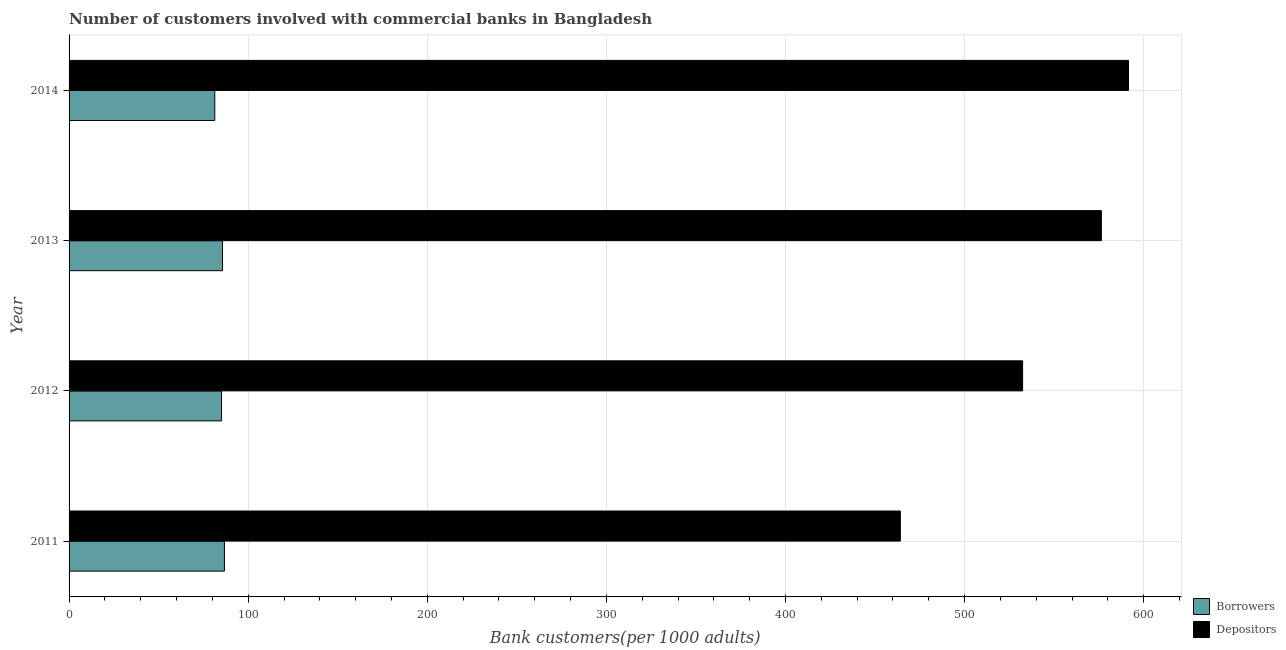How many groups of bars are there?
Your answer should be compact. 4. Are the number of bars on each tick of the Y-axis equal?
Give a very brief answer. Yes. How many bars are there on the 3rd tick from the top?
Your answer should be very brief. 2. What is the number of depositors in 2014?
Offer a terse response. 591.52. Across all years, what is the maximum number of borrowers?
Provide a short and direct response. 86.74. Across all years, what is the minimum number of depositors?
Your answer should be very brief. 464.13. What is the total number of borrowers in the graph?
Your answer should be very brief. 338.87. What is the difference between the number of borrowers in 2011 and that in 2013?
Give a very brief answer. 1.09. What is the difference between the number of borrowers in 2011 and the number of depositors in 2014?
Your answer should be compact. -504.78. What is the average number of borrowers per year?
Ensure brevity in your answer.  84.72. In the year 2012, what is the difference between the number of depositors and number of borrowers?
Offer a very short reply. 447.26. In how many years, is the number of depositors greater than 420 ?
Provide a succinct answer. 4. Is the number of depositors in 2011 less than that in 2012?
Your answer should be compact. Yes. What is the difference between the highest and the second highest number of depositors?
Keep it short and to the point. 15.15. What is the difference between the highest and the lowest number of borrowers?
Make the answer very short. 5.4. In how many years, is the number of borrowers greater than the average number of borrowers taken over all years?
Your answer should be compact. 3. Is the sum of the number of depositors in 2011 and 2014 greater than the maximum number of borrowers across all years?
Your answer should be very brief. Yes. What does the 2nd bar from the top in 2012 represents?
Your answer should be very brief. Borrowers. What does the 2nd bar from the bottom in 2013 represents?
Make the answer very short. Depositors. Are all the bars in the graph horizontal?
Make the answer very short. Yes. Are the values on the major ticks of X-axis written in scientific E-notation?
Offer a very short reply. No. Does the graph contain any zero values?
Your answer should be very brief. No. Where does the legend appear in the graph?
Ensure brevity in your answer.  Bottom right. How many legend labels are there?
Your answer should be compact. 2. What is the title of the graph?
Your answer should be compact. Number of customers involved with commercial banks in Bangladesh. Does "Underweight" appear as one of the legend labels in the graph?
Your response must be concise. No. What is the label or title of the X-axis?
Ensure brevity in your answer.  Bank customers(per 1000 adults). What is the Bank customers(per 1000 adults) of Borrowers in 2011?
Your answer should be compact. 86.74. What is the Bank customers(per 1000 adults) of Depositors in 2011?
Make the answer very short. 464.13. What is the Bank customers(per 1000 adults) of Borrowers in 2012?
Keep it short and to the point. 85.13. What is the Bank customers(per 1000 adults) in Depositors in 2012?
Offer a terse response. 532.4. What is the Bank customers(per 1000 adults) in Borrowers in 2013?
Ensure brevity in your answer.  85.65. What is the Bank customers(per 1000 adults) of Depositors in 2013?
Give a very brief answer. 576.37. What is the Bank customers(per 1000 adults) in Borrowers in 2014?
Give a very brief answer. 81.34. What is the Bank customers(per 1000 adults) of Depositors in 2014?
Offer a terse response. 591.52. Across all years, what is the maximum Bank customers(per 1000 adults) of Borrowers?
Provide a short and direct response. 86.74. Across all years, what is the maximum Bank customers(per 1000 adults) of Depositors?
Offer a very short reply. 591.52. Across all years, what is the minimum Bank customers(per 1000 adults) of Borrowers?
Your answer should be compact. 81.34. Across all years, what is the minimum Bank customers(per 1000 adults) in Depositors?
Offer a very short reply. 464.13. What is the total Bank customers(per 1000 adults) in Borrowers in the graph?
Provide a succinct answer. 338.87. What is the total Bank customers(per 1000 adults) in Depositors in the graph?
Provide a succinct answer. 2164.42. What is the difference between the Bank customers(per 1000 adults) of Borrowers in 2011 and that in 2012?
Provide a short and direct response. 1.61. What is the difference between the Bank customers(per 1000 adults) in Depositors in 2011 and that in 2012?
Your answer should be very brief. -68.27. What is the difference between the Bank customers(per 1000 adults) in Borrowers in 2011 and that in 2013?
Offer a very short reply. 1.09. What is the difference between the Bank customers(per 1000 adults) in Depositors in 2011 and that in 2013?
Make the answer very short. -112.24. What is the difference between the Bank customers(per 1000 adults) of Borrowers in 2011 and that in 2014?
Offer a very short reply. 5.4. What is the difference between the Bank customers(per 1000 adults) of Depositors in 2011 and that in 2014?
Make the answer very short. -127.39. What is the difference between the Bank customers(per 1000 adults) in Borrowers in 2012 and that in 2013?
Ensure brevity in your answer.  -0.52. What is the difference between the Bank customers(per 1000 adults) in Depositors in 2012 and that in 2013?
Provide a succinct answer. -43.98. What is the difference between the Bank customers(per 1000 adults) in Borrowers in 2012 and that in 2014?
Provide a succinct answer. 3.79. What is the difference between the Bank customers(per 1000 adults) in Depositors in 2012 and that in 2014?
Offer a very short reply. -59.12. What is the difference between the Bank customers(per 1000 adults) of Borrowers in 2013 and that in 2014?
Give a very brief answer. 4.31. What is the difference between the Bank customers(per 1000 adults) in Depositors in 2013 and that in 2014?
Ensure brevity in your answer.  -15.15. What is the difference between the Bank customers(per 1000 adults) in Borrowers in 2011 and the Bank customers(per 1000 adults) in Depositors in 2012?
Ensure brevity in your answer.  -445.66. What is the difference between the Bank customers(per 1000 adults) in Borrowers in 2011 and the Bank customers(per 1000 adults) in Depositors in 2013?
Your answer should be very brief. -489.63. What is the difference between the Bank customers(per 1000 adults) of Borrowers in 2011 and the Bank customers(per 1000 adults) of Depositors in 2014?
Your answer should be very brief. -504.78. What is the difference between the Bank customers(per 1000 adults) of Borrowers in 2012 and the Bank customers(per 1000 adults) of Depositors in 2013?
Make the answer very short. -491.24. What is the difference between the Bank customers(per 1000 adults) in Borrowers in 2012 and the Bank customers(per 1000 adults) in Depositors in 2014?
Offer a terse response. -506.39. What is the difference between the Bank customers(per 1000 adults) of Borrowers in 2013 and the Bank customers(per 1000 adults) of Depositors in 2014?
Ensure brevity in your answer.  -505.87. What is the average Bank customers(per 1000 adults) of Borrowers per year?
Offer a very short reply. 84.72. What is the average Bank customers(per 1000 adults) in Depositors per year?
Make the answer very short. 541.11. In the year 2011, what is the difference between the Bank customers(per 1000 adults) in Borrowers and Bank customers(per 1000 adults) in Depositors?
Offer a very short reply. -377.39. In the year 2012, what is the difference between the Bank customers(per 1000 adults) in Borrowers and Bank customers(per 1000 adults) in Depositors?
Provide a short and direct response. -447.26. In the year 2013, what is the difference between the Bank customers(per 1000 adults) in Borrowers and Bank customers(per 1000 adults) in Depositors?
Your answer should be compact. -490.72. In the year 2014, what is the difference between the Bank customers(per 1000 adults) in Borrowers and Bank customers(per 1000 adults) in Depositors?
Give a very brief answer. -510.18. What is the ratio of the Bank customers(per 1000 adults) in Borrowers in 2011 to that in 2012?
Your answer should be very brief. 1.02. What is the ratio of the Bank customers(per 1000 adults) of Depositors in 2011 to that in 2012?
Offer a terse response. 0.87. What is the ratio of the Bank customers(per 1000 adults) in Borrowers in 2011 to that in 2013?
Give a very brief answer. 1.01. What is the ratio of the Bank customers(per 1000 adults) of Depositors in 2011 to that in 2013?
Ensure brevity in your answer.  0.81. What is the ratio of the Bank customers(per 1000 adults) in Borrowers in 2011 to that in 2014?
Your response must be concise. 1.07. What is the ratio of the Bank customers(per 1000 adults) in Depositors in 2011 to that in 2014?
Provide a succinct answer. 0.78. What is the ratio of the Bank customers(per 1000 adults) of Borrowers in 2012 to that in 2013?
Provide a succinct answer. 0.99. What is the ratio of the Bank customers(per 1000 adults) of Depositors in 2012 to that in 2013?
Ensure brevity in your answer.  0.92. What is the ratio of the Bank customers(per 1000 adults) in Borrowers in 2012 to that in 2014?
Offer a terse response. 1.05. What is the ratio of the Bank customers(per 1000 adults) in Depositors in 2012 to that in 2014?
Offer a terse response. 0.9. What is the ratio of the Bank customers(per 1000 adults) of Borrowers in 2013 to that in 2014?
Make the answer very short. 1.05. What is the ratio of the Bank customers(per 1000 adults) of Depositors in 2013 to that in 2014?
Give a very brief answer. 0.97. What is the difference between the highest and the second highest Bank customers(per 1000 adults) in Borrowers?
Your response must be concise. 1.09. What is the difference between the highest and the second highest Bank customers(per 1000 adults) in Depositors?
Ensure brevity in your answer.  15.15. What is the difference between the highest and the lowest Bank customers(per 1000 adults) in Borrowers?
Your response must be concise. 5.4. What is the difference between the highest and the lowest Bank customers(per 1000 adults) of Depositors?
Provide a short and direct response. 127.39. 